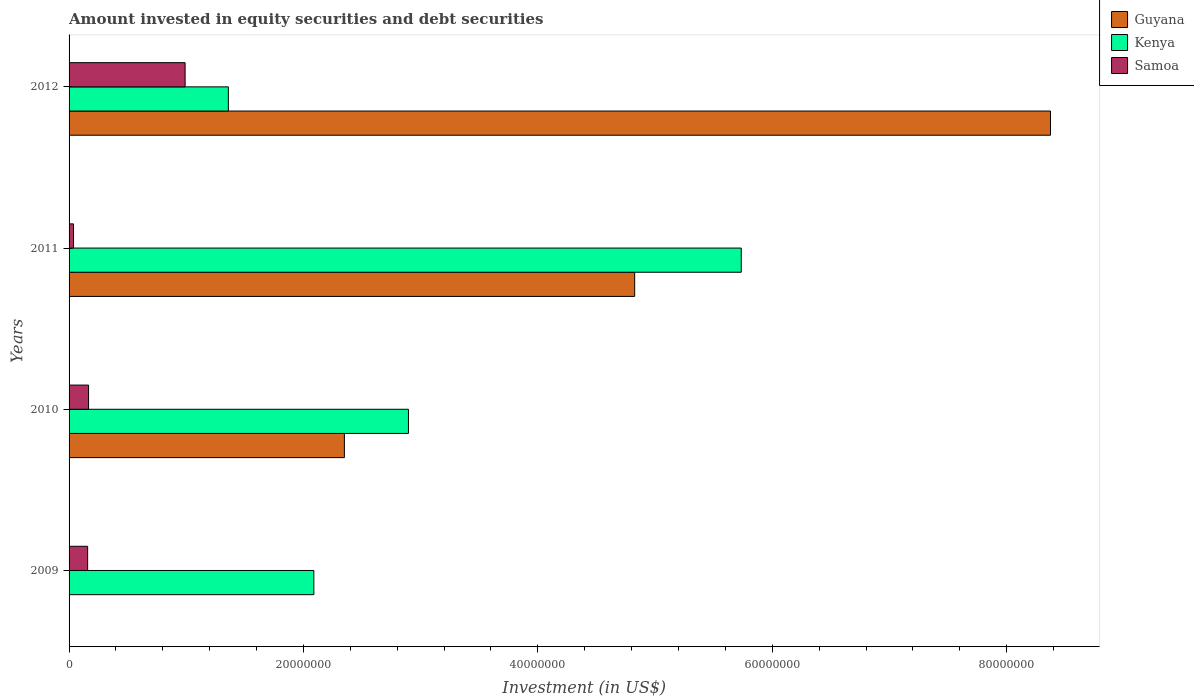How many different coloured bars are there?
Provide a short and direct response. 3. Are the number of bars on each tick of the Y-axis equal?
Your answer should be very brief. No. What is the label of the 3rd group of bars from the top?
Provide a succinct answer. 2010. In how many cases, is the number of bars for a given year not equal to the number of legend labels?
Your answer should be compact. 1. What is the amount invested in equity securities and debt securities in Kenya in 2010?
Your answer should be very brief. 2.90e+07. Across all years, what is the maximum amount invested in equity securities and debt securities in Guyana?
Give a very brief answer. 8.37e+07. Across all years, what is the minimum amount invested in equity securities and debt securities in Kenya?
Provide a succinct answer. 1.36e+07. What is the total amount invested in equity securities and debt securities in Guyana in the graph?
Your response must be concise. 1.55e+08. What is the difference between the amount invested in equity securities and debt securities in Kenya in 2009 and that in 2011?
Ensure brevity in your answer.  -3.65e+07. What is the difference between the amount invested in equity securities and debt securities in Guyana in 2009 and the amount invested in equity securities and debt securities in Kenya in 2011?
Provide a short and direct response. -5.74e+07. What is the average amount invested in equity securities and debt securities in Samoa per year?
Your answer should be compact. 3.38e+06. In the year 2012, what is the difference between the amount invested in equity securities and debt securities in Guyana and amount invested in equity securities and debt securities in Kenya?
Offer a very short reply. 7.01e+07. What is the ratio of the amount invested in equity securities and debt securities in Guyana in 2010 to that in 2011?
Your answer should be very brief. 0.49. What is the difference between the highest and the second highest amount invested in equity securities and debt securities in Guyana?
Provide a succinct answer. 3.55e+07. What is the difference between the highest and the lowest amount invested in equity securities and debt securities in Guyana?
Provide a succinct answer. 8.37e+07. How many bars are there?
Offer a terse response. 11. What is the difference between two consecutive major ticks on the X-axis?
Your answer should be very brief. 2.00e+07. Does the graph contain any zero values?
Offer a terse response. Yes. Where does the legend appear in the graph?
Provide a short and direct response. Top right. How many legend labels are there?
Ensure brevity in your answer.  3. What is the title of the graph?
Your answer should be very brief. Amount invested in equity securities and debt securities. What is the label or title of the X-axis?
Keep it short and to the point. Investment (in US$). What is the Investment (in US$) in Guyana in 2009?
Offer a terse response. 0. What is the Investment (in US$) in Kenya in 2009?
Provide a short and direct response. 2.09e+07. What is the Investment (in US$) in Samoa in 2009?
Your response must be concise. 1.58e+06. What is the Investment (in US$) of Guyana in 2010?
Offer a terse response. 2.35e+07. What is the Investment (in US$) of Kenya in 2010?
Your response must be concise. 2.90e+07. What is the Investment (in US$) in Samoa in 2010?
Offer a very short reply. 1.66e+06. What is the Investment (in US$) of Guyana in 2011?
Your answer should be compact. 4.83e+07. What is the Investment (in US$) in Kenya in 2011?
Offer a very short reply. 5.74e+07. What is the Investment (in US$) of Samoa in 2011?
Provide a short and direct response. 3.80e+05. What is the Investment (in US$) in Guyana in 2012?
Offer a very short reply. 8.37e+07. What is the Investment (in US$) in Kenya in 2012?
Ensure brevity in your answer.  1.36e+07. What is the Investment (in US$) of Samoa in 2012?
Provide a short and direct response. 9.90e+06. Across all years, what is the maximum Investment (in US$) of Guyana?
Provide a succinct answer. 8.37e+07. Across all years, what is the maximum Investment (in US$) of Kenya?
Your answer should be compact. 5.74e+07. Across all years, what is the maximum Investment (in US$) of Samoa?
Make the answer very short. 9.90e+06. Across all years, what is the minimum Investment (in US$) of Kenya?
Your answer should be compact. 1.36e+07. Across all years, what is the minimum Investment (in US$) of Samoa?
Provide a succinct answer. 3.80e+05. What is the total Investment (in US$) in Guyana in the graph?
Your answer should be very brief. 1.55e+08. What is the total Investment (in US$) in Kenya in the graph?
Your answer should be very brief. 1.21e+08. What is the total Investment (in US$) of Samoa in the graph?
Keep it short and to the point. 1.35e+07. What is the difference between the Investment (in US$) in Kenya in 2009 and that in 2010?
Your response must be concise. -8.07e+06. What is the difference between the Investment (in US$) of Samoa in 2009 and that in 2010?
Ensure brevity in your answer.  -7.89e+04. What is the difference between the Investment (in US$) in Kenya in 2009 and that in 2011?
Your answer should be very brief. -3.65e+07. What is the difference between the Investment (in US$) in Samoa in 2009 and that in 2011?
Give a very brief answer. 1.20e+06. What is the difference between the Investment (in US$) in Kenya in 2009 and that in 2012?
Offer a terse response. 7.29e+06. What is the difference between the Investment (in US$) in Samoa in 2009 and that in 2012?
Give a very brief answer. -8.32e+06. What is the difference between the Investment (in US$) of Guyana in 2010 and that in 2011?
Give a very brief answer. -2.48e+07. What is the difference between the Investment (in US$) in Kenya in 2010 and that in 2011?
Offer a very short reply. -2.84e+07. What is the difference between the Investment (in US$) in Samoa in 2010 and that in 2011?
Keep it short and to the point. 1.28e+06. What is the difference between the Investment (in US$) of Guyana in 2010 and that in 2012?
Provide a short and direct response. -6.02e+07. What is the difference between the Investment (in US$) of Kenya in 2010 and that in 2012?
Provide a succinct answer. 1.54e+07. What is the difference between the Investment (in US$) of Samoa in 2010 and that in 2012?
Offer a very short reply. -8.24e+06. What is the difference between the Investment (in US$) of Guyana in 2011 and that in 2012?
Your response must be concise. -3.55e+07. What is the difference between the Investment (in US$) of Kenya in 2011 and that in 2012?
Provide a short and direct response. 4.38e+07. What is the difference between the Investment (in US$) of Samoa in 2011 and that in 2012?
Provide a succinct answer. -9.52e+06. What is the difference between the Investment (in US$) of Kenya in 2009 and the Investment (in US$) of Samoa in 2010?
Your answer should be very brief. 1.92e+07. What is the difference between the Investment (in US$) of Kenya in 2009 and the Investment (in US$) of Samoa in 2011?
Give a very brief answer. 2.05e+07. What is the difference between the Investment (in US$) of Kenya in 2009 and the Investment (in US$) of Samoa in 2012?
Give a very brief answer. 1.10e+07. What is the difference between the Investment (in US$) of Guyana in 2010 and the Investment (in US$) of Kenya in 2011?
Your answer should be compact. -3.39e+07. What is the difference between the Investment (in US$) in Guyana in 2010 and the Investment (in US$) in Samoa in 2011?
Make the answer very short. 2.31e+07. What is the difference between the Investment (in US$) of Kenya in 2010 and the Investment (in US$) of Samoa in 2011?
Give a very brief answer. 2.86e+07. What is the difference between the Investment (in US$) in Guyana in 2010 and the Investment (in US$) in Kenya in 2012?
Make the answer very short. 9.90e+06. What is the difference between the Investment (in US$) in Guyana in 2010 and the Investment (in US$) in Samoa in 2012?
Your answer should be compact. 1.36e+07. What is the difference between the Investment (in US$) in Kenya in 2010 and the Investment (in US$) in Samoa in 2012?
Offer a terse response. 1.91e+07. What is the difference between the Investment (in US$) in Guyana in 2011 and the Investment (in US$) in Kenya in 2012?
Ensure brevity in your answer.  3.47e+07. What is the difference between the Investment (in US$) in Guyana in 2011 and the Investment (in US$) in Samoa in 2012?
Your response must be concise. 3.84e+07. What is the difference between the Investment (in US$) in Kenya in 2011 and the Investment (in US$) in Samoa in 2012?
Provide a short and direct response. 4.75e+07. What is the average Investment (in US$) of Guyana per year?
Your answer should be very brief. 3.89e+07. What is the average Investment (in US$) of Kenya per year?
Give a very brief answer. 3.02e+07. What is the average Investment (in US$) in Samoa per year?
Your answer should be very brief. 3.38e+06. In the year 2009, what is the difference between the Investment (in US$) of Kenya and Investment (in US$) of Samoa?
Offer a very short reply. 1.93e+07. In the year 2010, what is the difference between the Investment (in US$) of Guyana and Investment (in US$) of Kenya?
Keep it short and to the point. -5.47e+06. In the year 2010, what is the difference between the Investment (in US$) of Guyana and Investment (in US$) of Samoa?
Your answer should be compact. 2.18e+07. In the year 2010, what is the difference between the Investment (in US$) in Kenya and Investment (in US$) in Samoa?
Your answer should be compact. 2.73e+07. In the year 2011, what is the difference between the Investment (in US$) of Guyana and Investment (in US$) of Kenya?
Give a very brief answer. -9.10e+06. In the year 2011, what is the difference between the Investment (in US$) in Guyana and Investment (in US$) in Samoa?
Keep it short and to the point. 4.79e+07. In the year 2011, what is the difference between the Investment (in US$) in Kenya and Investment (in US$) in Samoa?
Provide a short and direct response. 5.70e+07. In the year 2012, what is the difference between the Investment (in US$) of Guyana and Investment (in US$) of Kenya?
Your answer should be compact. 7.01e+07. In the year 2012, what is the difference between the Investment (in US$) of Guyana and Investment (in US$) of Samoa?
Your response must be concise. 7.38e+07. In the year 2012, what is the difference between the Investment (in US$) in Kenya and Investment (in US$) in Samoa?
Make the answer very short. 3.69e+06. What is the ratio of the Investment (in US$) of Kenya in 2009 to that in 2010?
Give a very brief answer. 0.72. What is the ratio of the Investment (in US$) in Samoa in 2009 to that in 2010?
Your answer should be very brief. 0.95. What is the ratio of the Investment (in US$) of Kenya in 2009 to that in 2011?
Give a very brief answer. 0.36. What is the ratio of the Investment (in US$) in Samoa in 2009 to that in 2011?
Provide a succinct answer. 4.17. What is the ratio of the Investment (in US$) in Kenya in 2009 to that in 2012?
Give a very brief answer. 1.54. What is the ratio of the Investment (in US$) in Samoa in 2009 to that in 2012?
Ensure brevity in your answer.  0.16. What is the ratio of the Investment (in US$) in Guyana in 2010 to that in 2011?
Your response must be concise. 0.49. What is the ratio of the Investment (in US$) of Kenya in 2010 to that in 2011?
Offer a very short reply. 0.5. What is the ratio of the Investment (in US$) of Samoa in 2010 to that in 2011?
Make the answer very short. 4.37. What is the ratio of the Investment (in US$) in Guyana in 2010 to that in 2012?
Your answer should be compact. 0.28. What is the ratio of the Investment (in US$) of Kenya in 2010 to that in 2012?
Offer a very short reply. 2.13. What is the ratio of the Investment (in US$) of Samoa in 2010 to that in 2012?
Provide a short and direct response. 0.17. What is the ratio of the Investment (in US$) of Guyana in 2011 to that in 2012?
Provide a succinct answer. 0.58. What is the ratio of the Investment (in US$) of Kenya in 2011 to that in 2012?
Provide a short and direct response. 4.22. What is the ratio of the Investment (in US$) of Samoa in 2011 to that in 2012?
Provide a short and direct response. 0.04. What is the difference between the highest and the second highest Investment (in US$) in Guyana?
Your response must be concise. 3.55e+07. What is the difference between the highest and the second highest Investment (in US$) of Kenya?
Ensure brevity in your answer.  2.84e+07. What is the difference between the highest and the second highest Investment (in US$) in Samoa?
Provide a short and direct response. 8.24e+06. What is the difference between the highest and the lowest Investment (in US$) in Guyana?
Give a very brief answer. 8.37e+07. What is the difference between the highest and the lowest Investment (in US$) in Kenya?
Provide a short and direct response. 4.38e+07. What is the difference between the highest and the lowest Investment (in US$) in Samoa?
Provide a short and direct response. 9.52e+06. 